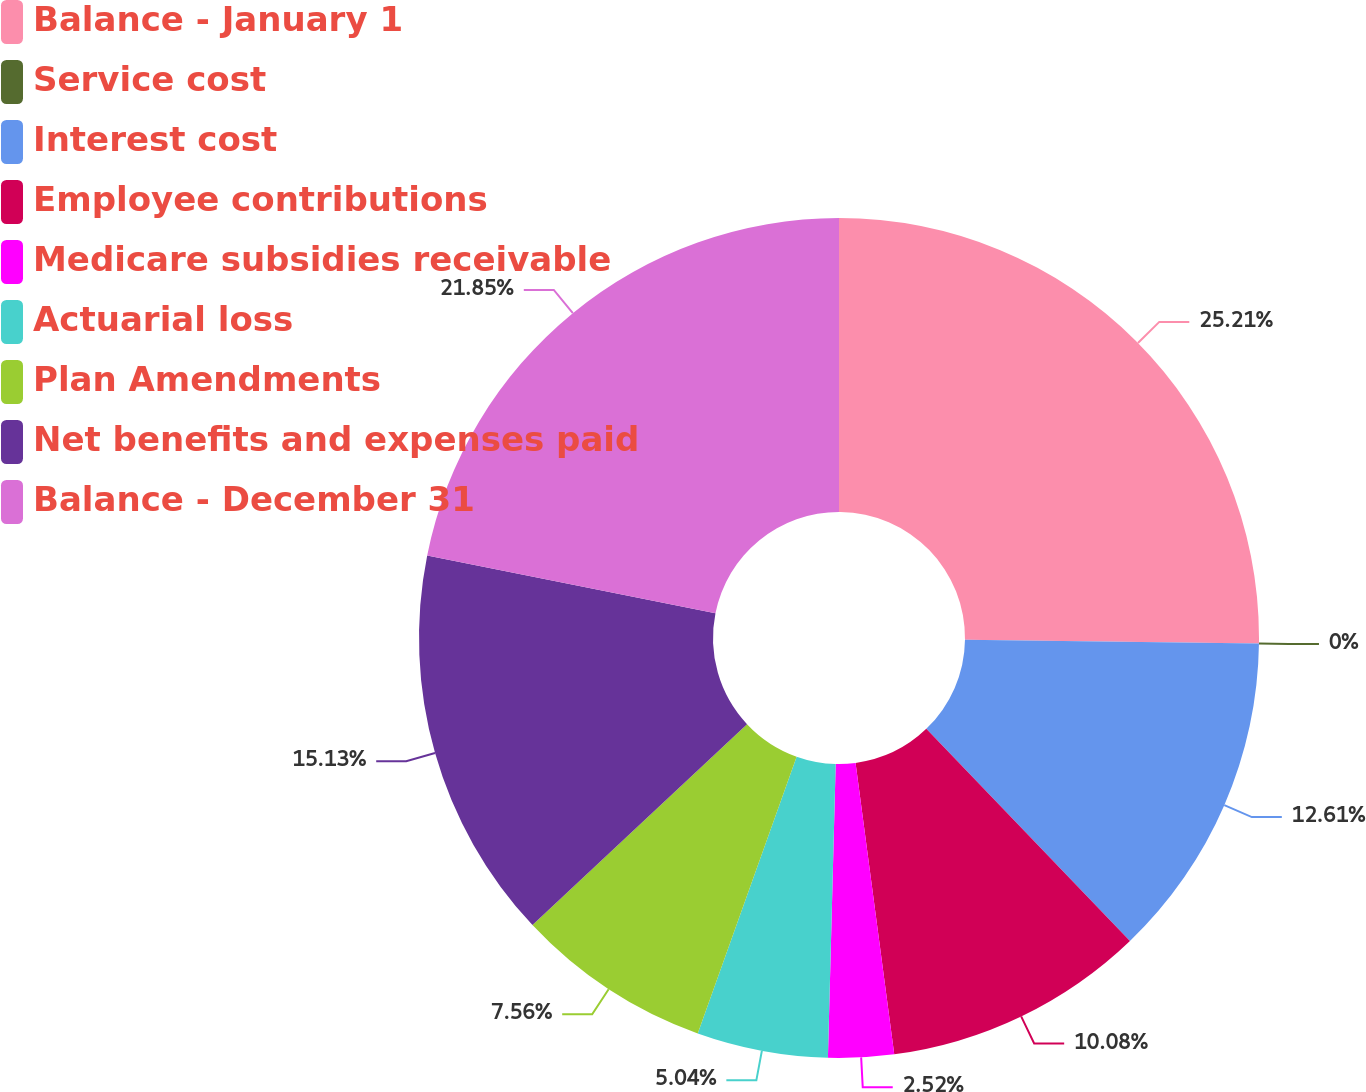<chart> <loc_0><loc_0><loc_500><loc_500><pie_chart><fcel>Balance - January 1<fcel>Service cost<fcel>Interest cost<fcel>Employee contributions<fcel>Medicare subsidies receivable<fcel>Actuarial loss<fcel>Plan Amendments<fcel>Net benefits and expenses paid<fcel>Balance - December 31<nl><fcel>25.21%<fcel>0.0%<fcel>12.61%<fcel>10.08%<fcel>2.52%<fcel>5.04%<fcel>7.56%<fcel>15.13%<fcel>21.85%<nl></chart> 